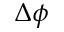<formula> <loc_0><loc_0><loc_500><loc_500>\Delta \phi</formula> 